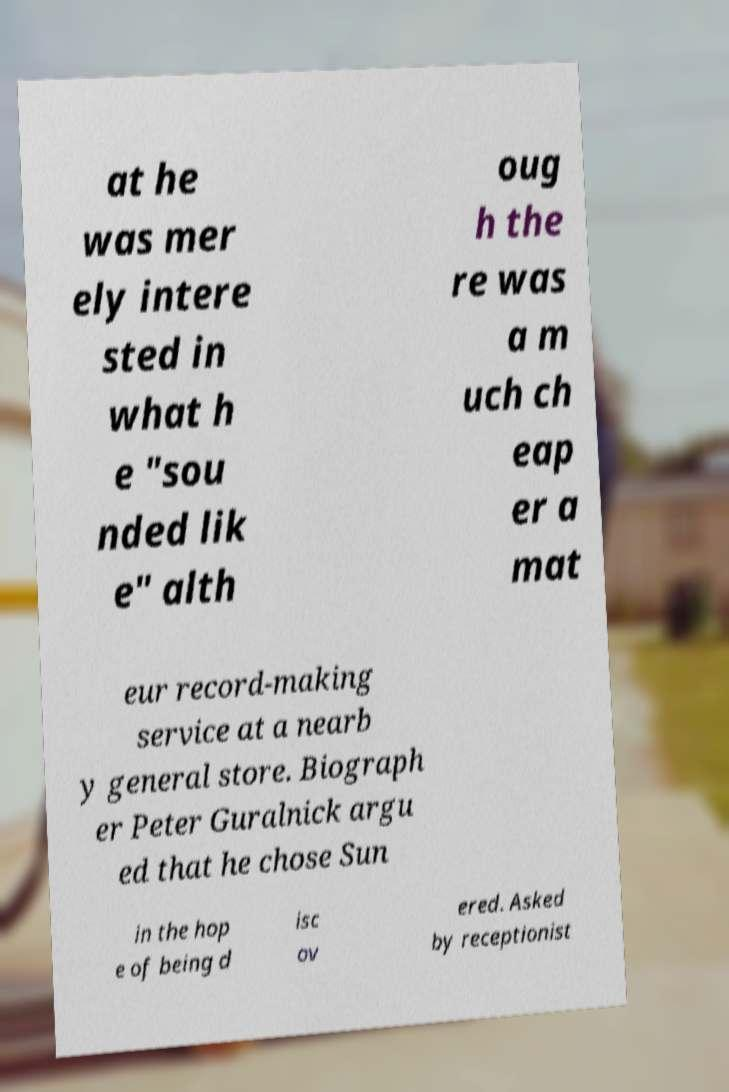For documentation purposes, I need the text within this image transcribed. Could you provide that? at he was mer ely intere sted in what h e "sou nded lik e" alth oug h the re was a m uch ch eap er a mat eur record-making service at a nearb y general store. Biograph er Peter Guralnick argu ed that he chose Sun in the hop e of being d isc ov ered. Asked by receptionist 